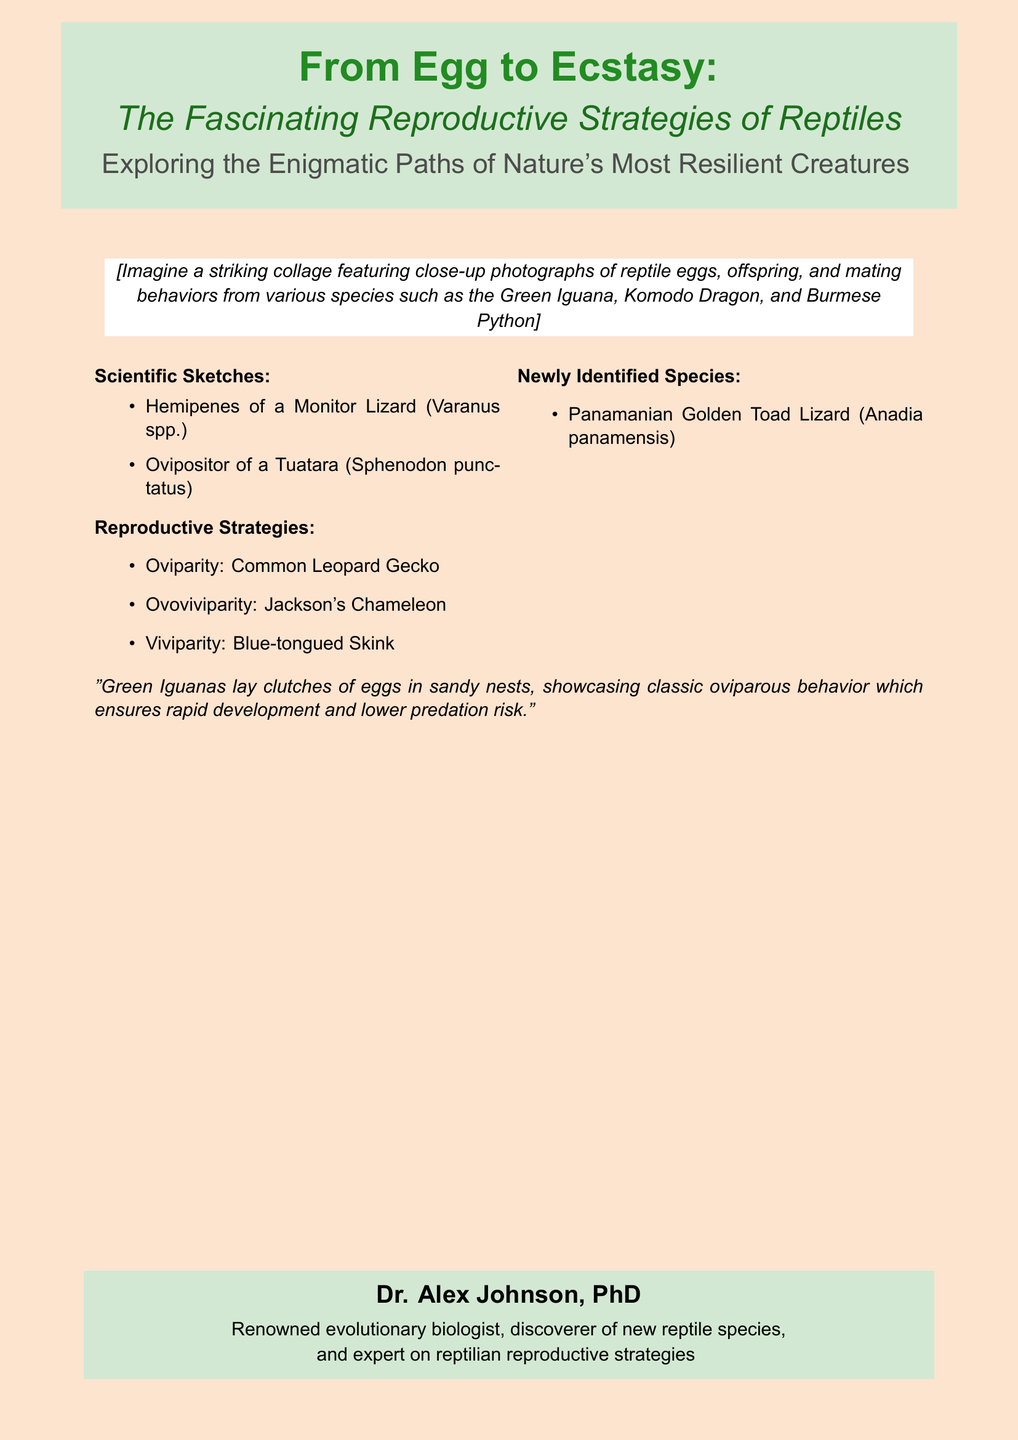What is the title of the book? The title is prominently displayed at the top of the document, highlighting the main theme.
Answer: From Egg to Ecstasy What is the subtitle of the book? The subtitle provides insight into the specific focus of the book, located just below the title.
Answer: The Fascinating Reproductive Strategies of Reptiles Who is the author of the book? The author is mentioned at the bottom of the cover, indicating their expertise and credentials.
Answer: Dr. Alex Johnson, PhD Which reptile is highlighted for oviparous behavior? This information illustrates a specific reproductive strategy demonstrated by a well-known reptile.
Answer: Green Iguana What newly identified species is mentioned? This species is listed under the section discussing new discoveries in reptilian biology.
Answer: Panamanian Golden Toad Lizard Name one reproductive strategy discussed in the document. The document lists different strategies employed by reptiles, a crucial aspect of their biology.
Answer: Oviparity How many distinct reproductive strategies are listed? The document enumerates various strategies to showcase the diversity among reptile species.
Answer: Three What color is used for the book cover background? The page color provides a unique aesthetic that enhances the overall presentation of the cover.
Answer: Sand color What sketches are included on the cover? This information highlights the scientific illustrations that complement the main theme of the book.
Answer: Hemipenes of a Monitor Lizard, Ovipositor of a Tuatara 